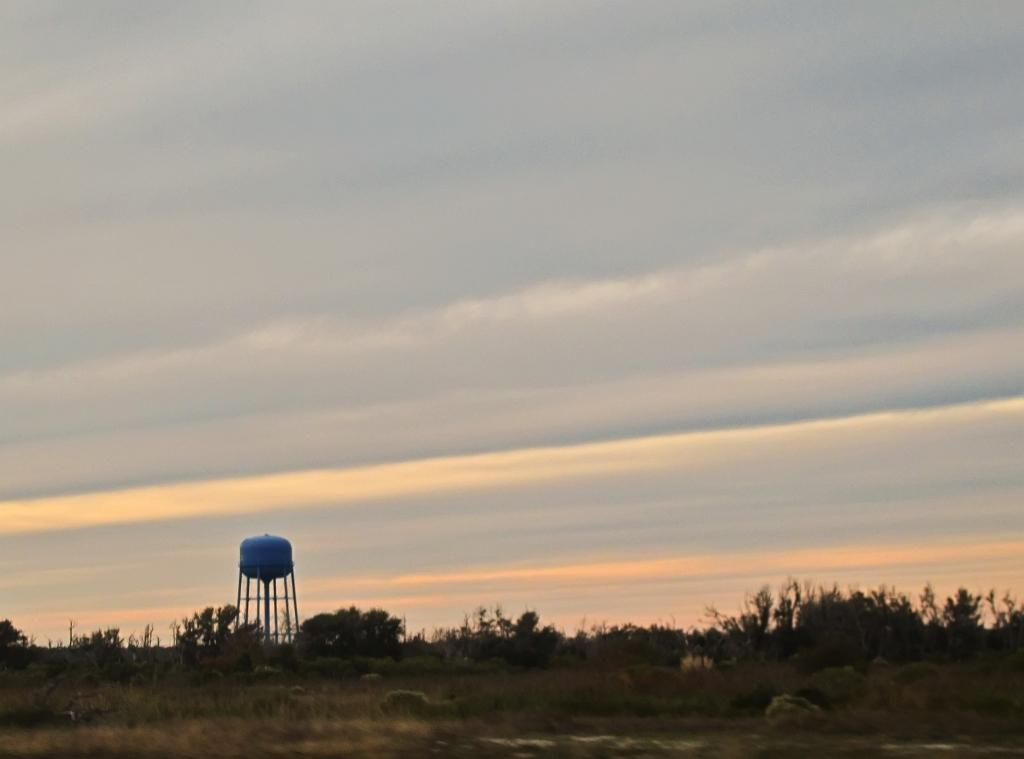What type of vegetation can be seen in the image? There are trees in the image. What is the large, cylindrical object in the image? There is a water tank in the image. What is visible at the top of the image? The sky is visible at the top of the image. What can be seen in the sky? There are clouds in the sky. What type of terrain is visible at the bottom of the image? There is grass at the bottom of the image. What is the surface on which the grass is growing? There is ground visible in the image. What type of hat is the tree wearing in the image? There are no hats present in the image, as trees are not capable of wearing hats. 